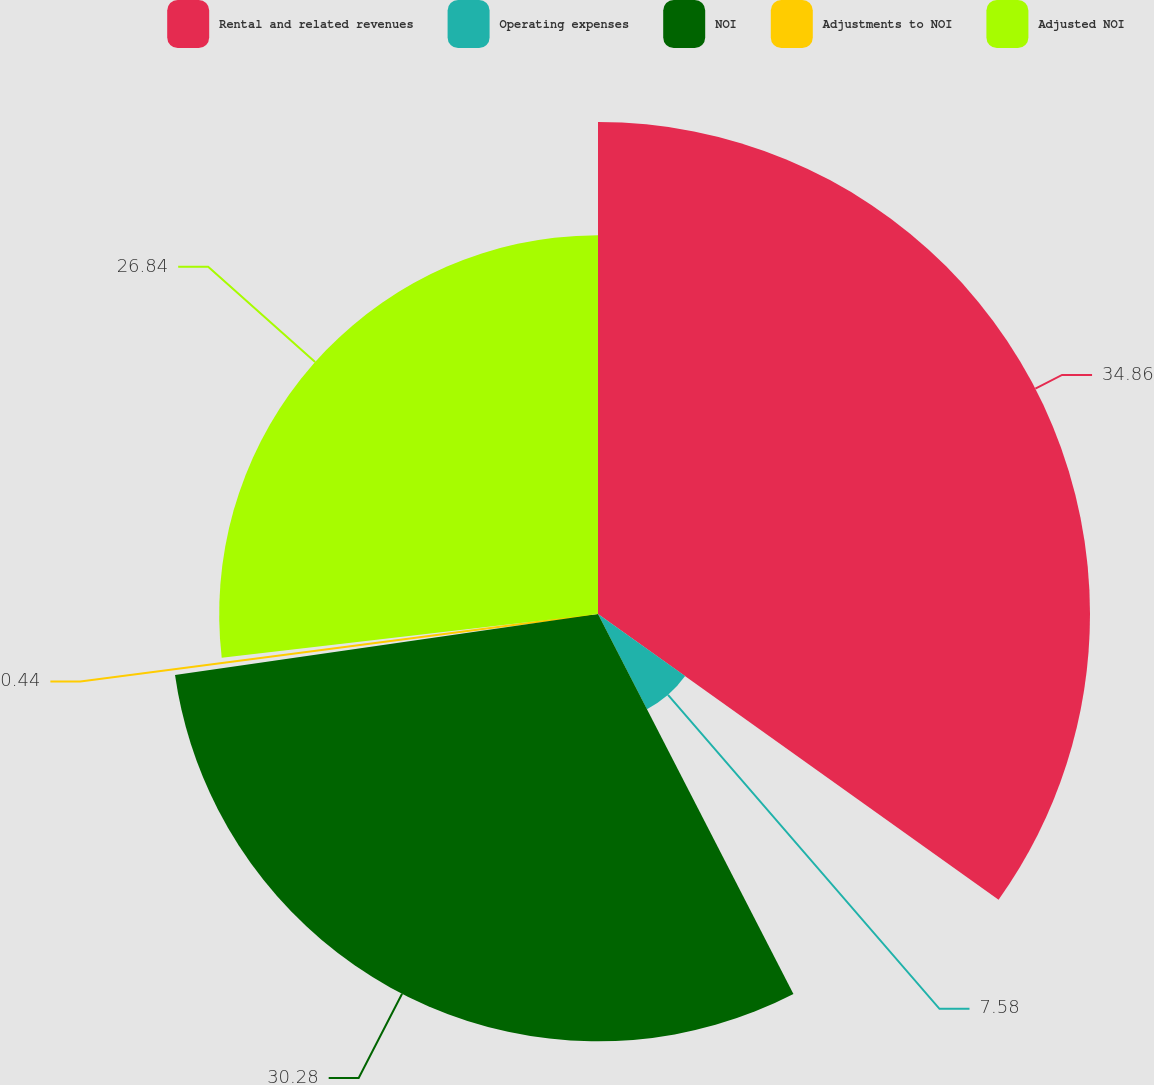Convert chart. <chart><loc_0><loc_0><loc_500><loc_500><pie_chart><fcel>Rental and related revenues<fcel>Operating expenses<fcel>NOI<fcel>Adjustments to NOI<fcel>Adjusted NOI<nl><fcel>34.86%<fcel>7.58%<fcel>30.28%<fcel>0.44%<fcel>26.84%<nl></chart> 